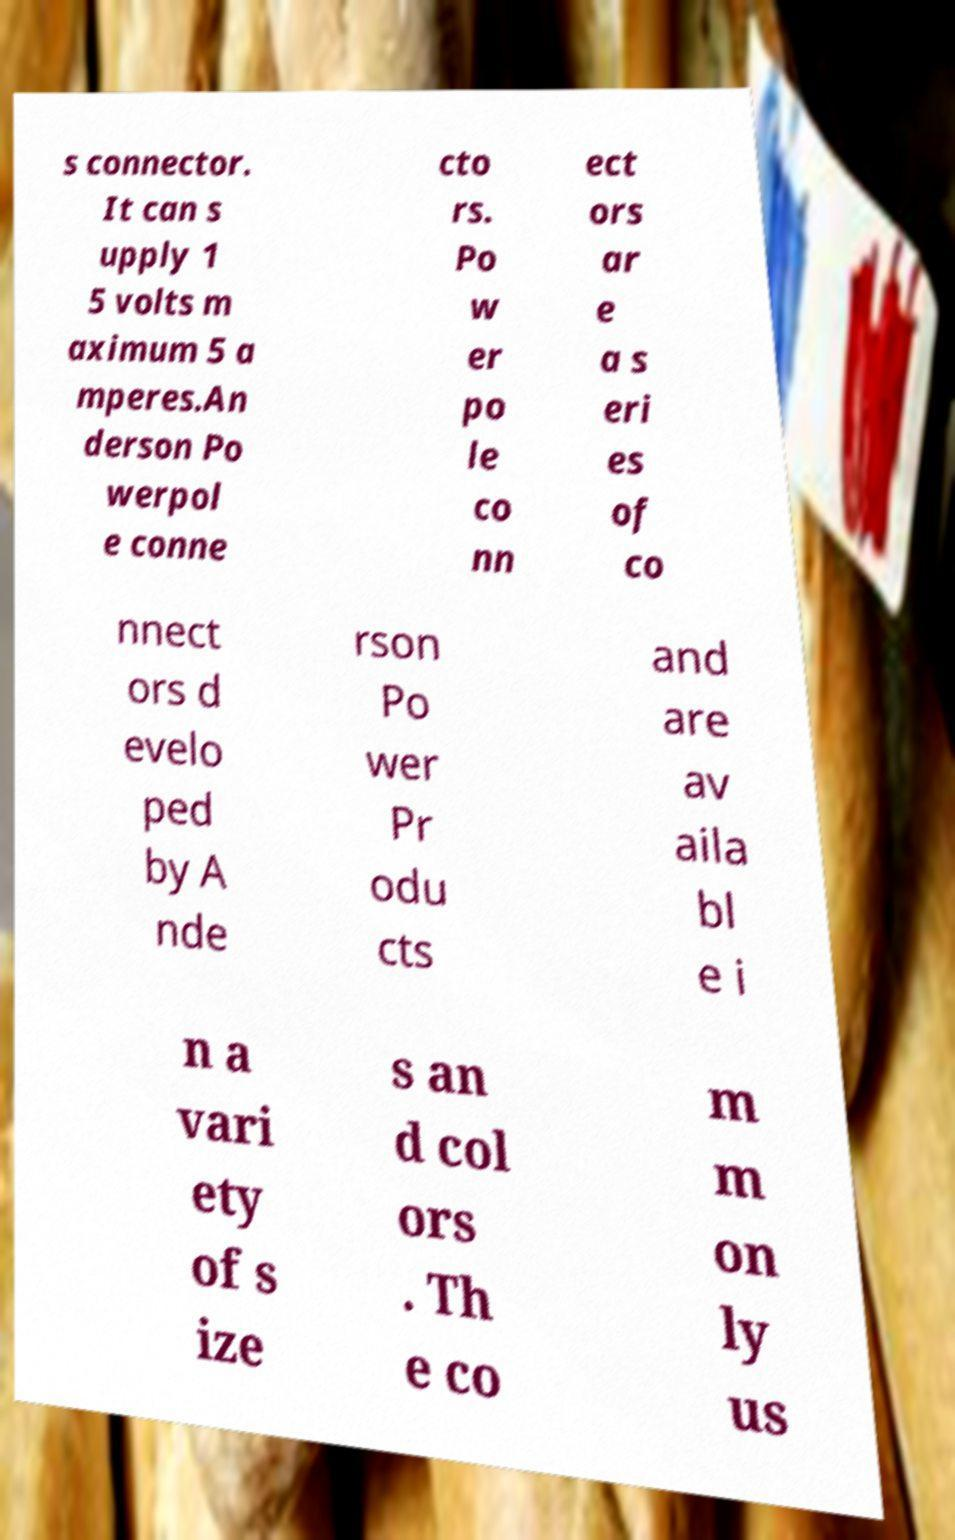Please read and relay the text visible in this image. What does it say? s connector. It can s upply 1 5 volts m aximum 5 a mperes.An derson Po werpol e conne cto rs. Po w er po le co nn ect ors ar e a s eri es of co nnect ors d evelo ped by A nde rson Po wer Pr odu cts and are av aila bl e i n a vari ety of s ize s an d col ors . Th e co m m on ly us 